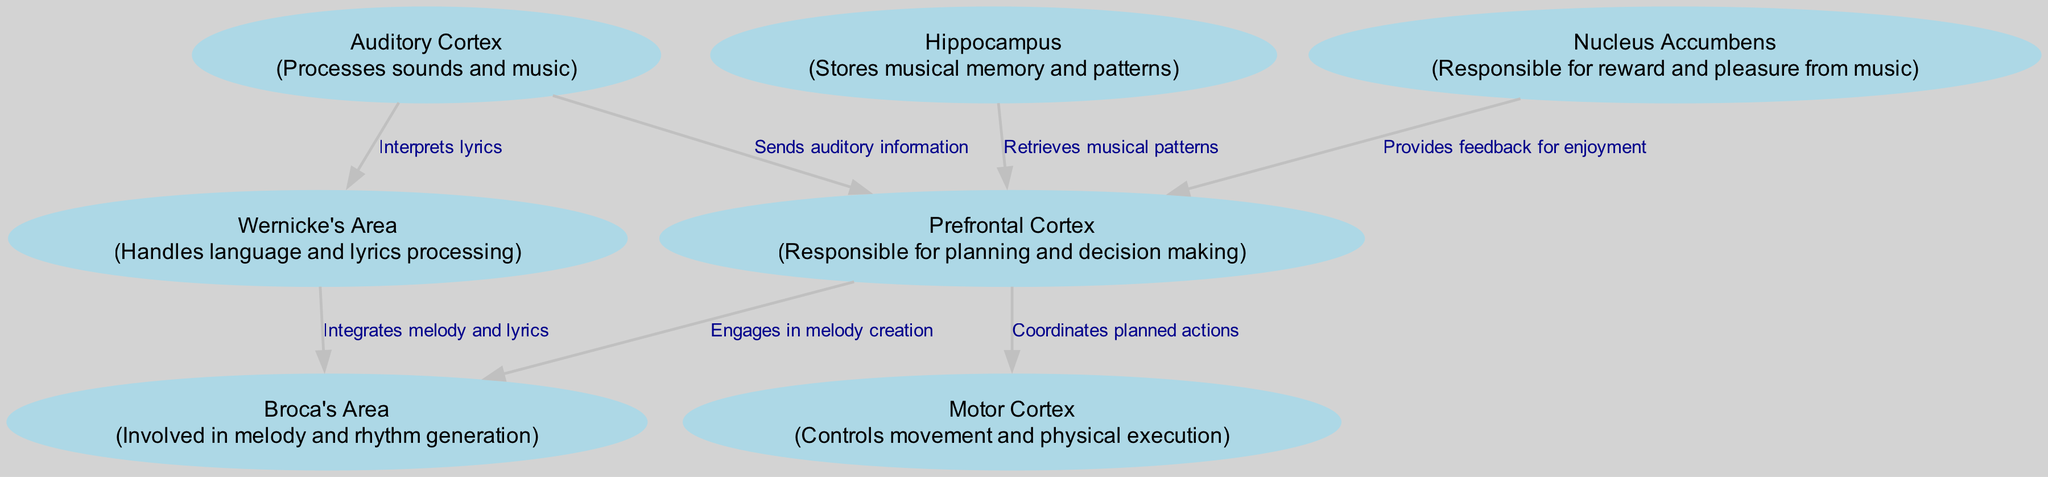What is the first node in the diagram? The first node listed in the data is the Auditory Cortex, which processes sounds and music.
Answer: Auditory Cortex How many nodes are present in the diagram? The data shows a total of 7 nodes, which are the different brain areas involved in music composition.
Answer: 7 What does the Prefrontal Cortex send to the Motor Cortex? The Prefrontal Cortex coordinates planned actions and sends this coordination to the Motor Cortex to execute those actions.
Answer: Planned actions Which area handles language processing? Wernicke's Area is the node specifically labeled as handling language and lyrics processing in the diagram.
Answer: Wernicke's Area What is the role of the Nucleus Accumbens in music composition? The Nucleus Accumbens is responsible for providing the reward and pleasure feedback from music, influencing the emotional response to the music composed.
Answer: Reward and pleasure What flows from the Auditory Cortex to the Prefrontal Cortex? The arrows show that auditory information flows from the Auditory Cortex to the Prefrontal Cortex for planning purposes in music composition.
Answer: Auditory information Which area is involved in melody generation and how is it connected to the Prefrontal Cortex? Broca's Area is involved in melody generation, and it is connected to the Prefrontal Cortex as the latter engages in melody creation based on information from it.
Answer: Broca's Area What connects the Hippocampus to the Prefrontal Cortex? The Hippocampus retrieves musical patterns and sends this retrieved information to the Prefrontal Cortex for further processing in the composition process.
Answer: Musical patterns Which two areas work together to integrate melody and lyrics? Wernicke's Area interprets lyrics and integrates them with melody generated by Broca's Area, creating a cohesive musical experience.
Answer: Wernicke's Area and Broca's Area 